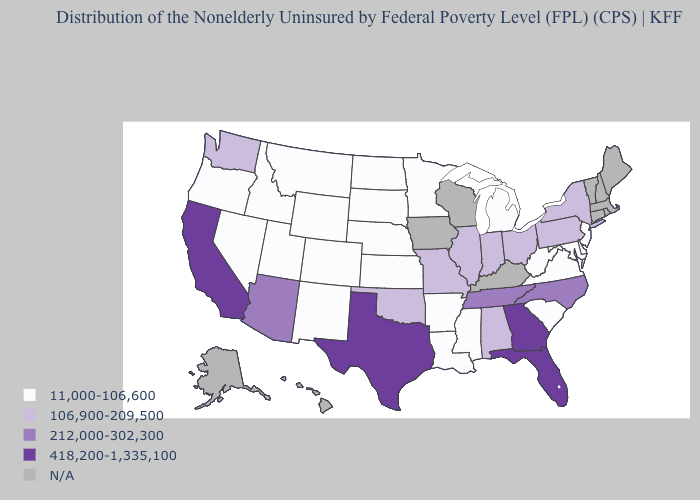What is the value of Georgia?
Keep it brief. 418,200-1,335,100. What is the lowest value in the USA?
Quick response, please. 11,000-106,600. What is the lowest value in the USA?
Keep it brief. 11,000-106,600. Which states have the lowest value in the MidWest?
Be succinct. Kansas, Michigan, Minnesota, Nebraska, North Dakota, South Dakota. Name the states that have a value in the range N/A?
Keep it brief. Alaska, Connecticut, Hawaii, Iowa, Kentucky, Maine, Massachusetts, New Hampshire, Rhode Island, Vermont, Wisconsin. Among the states that border New Jersey , does New York have the lowest value?
Short answer required. No. Which states have the lowest value in the Northeast?
Write a very short answer. New Jersey. What is the value of Florida?
Short answer required. 418,200-1,335,100. Name the states that have a value in the range 212,000-302,300?
Write a very short answer. Arizona, North Carolina, Tennessee. Among the states that border Nevada , which have the highest value?
Write a very short answer. California. Does Arizona have the lowest value in the USA?
Short answer required. No. What is the value of Illinois?
Write a very short answer. 106,900-209,500. Name the states that have a value in the range 212,000-302,300?
Keep it brief. Arizona, North Carolina, Tennessee. 